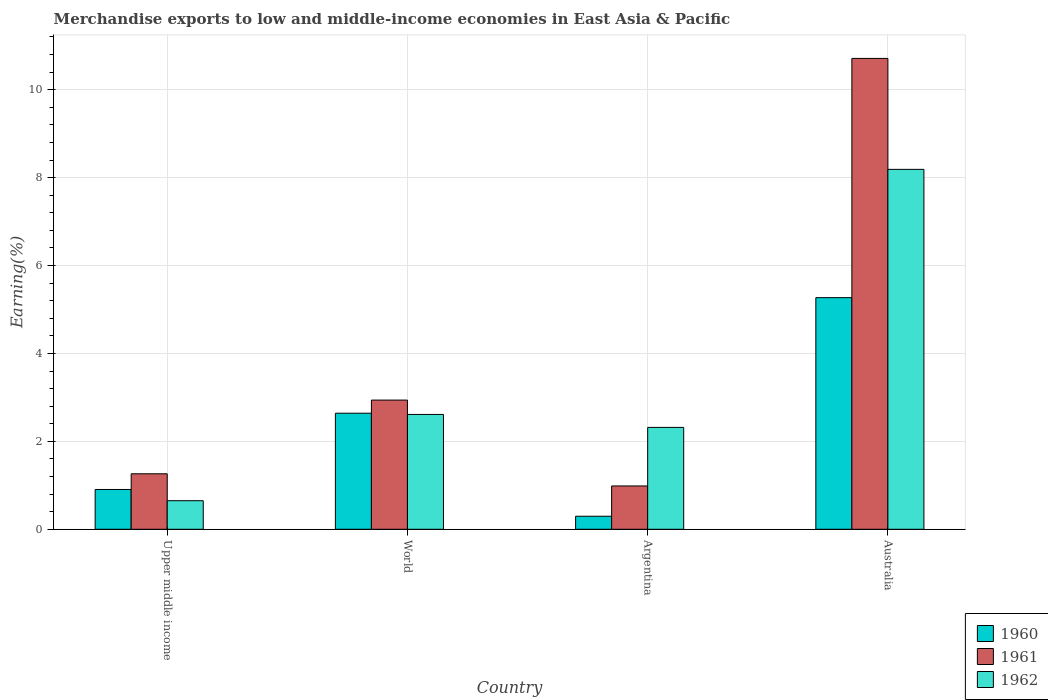How many different coloured bars are there?
Make the answer very short. 3. Are the number of bars per tick equal to the number of legend labels?
Give a very brief answer. Yes. Are the number of bars on each tick of the X-axis equal?
Offer a very short reply. Yes. What is the label of the 3rd group of bars from the left?
Your response must be concise. Argentina. What is the percentage of amount earned from merchandise exports in 1961 in Upper middle income?
Provide a short and direct response. 1.26. Across all countries, what is the maximum percentage of amount earned from merchandise exports in 1960?
Give a very brief answer. 5.27. Across all countries, what is the minimum percentage of amount earned from merchandise exports in 1961?
Provide a succinct answer. 0.99. In which country was the percentage of amount earned from merchandise exports in 1962 minimum?
Keep it short and to the point. Upper middle income. What is the total percentage of amount earned from merchandise exports in 1962 in the graph?
Ensure brevity in your answer.  13.77. What is the difference between the percentage of amount earned from merchandise exports in 1962 in Australia and that in World?
Your response must be concise. 5.58. What is the difference between the percentage of amount earned from merchandise exports in 1962 in Australia and the percentage of amount earned from merchandise exports in 1960 in Argentina?
Offer a very short reply. 7.89. What is the average percentage of amount earned from merchandise exports in 1961 per country?
Keep it short and to the point. 3.97. What is the difference between the percentage of amount earned from merchandise exports of/in 1960 and percentage of amount earned from merchandise exports of/in 1962 in Australia?
Provide a short and direct response. -2.92. What is the ratio of the percentage of amount earned from merchandise exports in 1961 in Australia to that in World?
Your response must be concise. 3.64. Is the percentage of amount earned from merchandise exports in 1961 in Australia less than that in Upper middle income?
Provide a short and direct response. No. What is the difference between the highest and the second highest percentage of amount earned from merchandise exports in 1962?
Keep it short and to the point. 5.58. What is the difference between the highest and the lowest percentage of amount earned from merchandise exports in 1961?
Offer a terse response. 9.73. In how many countries, is the percentage of amount earned from merchandise exports in 1960 greater than the average percentage of amount earned from merchandise exports in 1960 taken over all countries?
Provide a succinct answer. 2. Is the sum of the percentage of amount earned from merchandise exports in 1961 in Australia and Upper middle income greater than the maximum percentage of amount earned from merchandise exports in 1962 across all countries?
Provide a succinct answer. Yes. What does the 1st bar from the left in Argentina represents?
Offer a terse response. 1960. What is the difference between two consecutive major ticks on the Y-axis?
Give a very brief answer. 2. Does the graph contain grids?
Make the answer very short. Yes. Where does the legend appear in the graph?
Make the answer very short. Bottom right. How many legend labels are there?
Offer a terse response. 3. What is the title of the graph?
Provide a succinct answer. Merchandise exports to low and middle-income economies in East Asia & Pacific. Does "2001" appear as one of the legend labels in the graph?
Make the answer very short. No. What is the label or title of the Y-axis?
Offer a terse response. Earning(%). What is the Earning(%) of 1960 in Upper middle income?
Give a very brief answer. 0.91. What is the Earning(%) of 1961 in Upper middle income?
Ensure brevity in your answer.  1.26. What is the Earning(%) in 1962 in Upper middle income?
Provide a short and direct response. 0.65. What is the Earning(%) in 1960 in World?
Your response must be concise. 2.64. What is the Earning(%) in 1961 in World?
Give a very brief answer. 2.94. What is the Earning(%) of 1962 in World?
Provide a short and direct response. 2.61. What is the Earning(%) in 1960 in Argentina?
Your answer should be very brief. 0.3. What is the Earning(%) in 1961 in Argentina?
Keep it short and to the point. 0.99. What is the Earning(%) in 1962 in Argentina?
Provide a short and direct response. 2.32. What is the Earning(%) of 1960 in Australia?
Provide a short and direct response. 5.27. What is the Earning(%) in 1961 in Australia?
Provide a short and direct response. 10.71. What is the Earning(%) in 1962 in Australia?
Provide a succinct answer. 8.19. Across all countries, what is the maximum Earning(%) in 1960?
Keep it short and to the point. 5.27. Across all countries, what is the maximum Earning(%) of 1961?
Your response must be concise. 10.71. Across all countries, what is the maximum Earning(%) of 1962?
Your answer should be compact. 8.19. Across all countries, what is the minimum Earning(%) in 1960?
Offer a terse response. 0.3. Across all countries, what is the minimum Earning(%) in 1961?
Your response must be concise. 0.99. Across all countries, what is the minimum Earning(%) in 1962?
Offer a very short reply. 0.65. What is the total Earning(%) of 1960 in the graph?
Provide a short and direct response. 9.11. What is the total Earning(%) of 1961 in the graph?
Offer a terse response. 15.9. What is the total Earning(%) in 1962 in the graph?
Give a very brief answer. 13.77. What is the difference between the Earning(%) in 1960 in Upper middle income and that in World?
Ensure brevity in your answer.  -1.74. What is the difference between the Earning(%) of 1961 in Upper middle income and that in World?
Ensure brevity in your answer.  -1.68. What is the difference between the Earning(%) of 1962 in Upper middle income and that in World?
Ensure brevity in your answer.  -1.96. What is the difference between the Earning(%) of 1960 in Upper middle income and that in Argentina?
Provide a succinct answer. 0.61. What is the difference between the Earning(%) in 1961 in Upper middle income and that in Argentina?
Keep it short and to the point. 0.28. What is the difference between the Earning(%) in 1962 in Upper middle income and that in Argentina?
Your answer should be very brief. -1.67. What is the difference between the Earning(%) of 1960 in Upper middle income and that in Australia?
Provide a succinct answer. -4.36. What is the difference between the Earning(%) of 1961 in Upper middle income and that in Australia?
Provide a short and direct response. -9.45. What is the difference between the Earning(%) in 1962 in Upper middle income and that in Australia?
Ensure brevity in your answer.  -7.54. What is the difference between the Earning(%) in 1960 in World and that in Argentina?
Keep it short and to the point. 2.34. What is the difference between the Earning(%) in 1961 in World and that in Argentina?
Your answer should be very brief. 1.95. What is the difference between the Earning(%) in 1962 in World and that in Argentina?
Keep it short and to the point. 0.29. What is the difference between the Earning(%) of 1960 in World and that in Australia?
Make the answer very short. -2.63. What is the difference between the Earning(%) of 1961 in World and that in Australia?
Provide a short and direct response. -7.77. What is the difference between the Earning(%) of 1962 in World and that in Australia?
Your answer should be compact. -5.58. What is the difference between the Earning(%) in 1960 in Argentina and that in Australia?
Offer a terse response. -4.97. What is the difference between the Earning(%) in 1961 in Argentina and that in Australia?
Ensure brevity in your answer.  -9.73. What is the difference between the Earning(%) of 1962 in Argentina and that in Australia?
Your response must be concise. -5.87. What is the difference between the Earning(%) of 1960 in Upper middle income and the Earning(%) of 1961 in World?
Ensure brevity in your answer.  -2.03. What is the difference between the Earning(%) in 1960 in Upper middle income and the Earning(%) in 1962 in World?
Make the answer very short. -1.71. What is the difference between the Earning(%) in 1961 in Upper middle income and the Earning(%) in 1962 in World?
Offer a very short reply. -1.35. What is the difference between the Earning(%) of 1960 in Upper middle income and the Earning(%) of 1961 in Argentina?
Provide a short and direct response. -0.08. What is the difference between the Earning(%) in 1960 in Upper middle income and the Earning(%) in 1962 in Argentina?
Your answer should be very brief. -1.41. What is the difference between the Earning(%) of 1961 in Upper middle income and the Earning(%) of 1962 in Argentina?
Ensure brevity in your answer.  -1.06. What is the difference between the Earning(%) of 1960 in Upper middle income and the Earning(%) of 1961 in Australia?
Your response must be concise. -9.81. What is the difference between the Earning(%) in 1960 in Upper middle income and the Earning(%) in 1962 in Australia?
Provide a short and direct response. -7.28. What is the difference between the Earning(%) of 1961 in Upper middle income and the Earning(%) of 1962 in Australia?
Make the answer very short. -6.93. What is the difference between the Earning(%) of 1960 in World and the Earning(%) of 1961 in Argentina?
Offer a very short reply. 1.66. What is the difference between the Earning(%) of 1960 in World and the Earning(%) of 1962 in Argentina?
Offer a very short reply. 0.32. What is the difference between the Earning(%) of 1961 in World and the Earning(%) of 1962 in Argentina?
Your answer should be compact. 0.62. What is the difference between the Earning(%) of 1960 in World and the Earning(%) of 1961 in Australia?
Provide a succinct answer. -8.07. What is the difference between the Earning(%) in 1960 in World and the Earning(%) in 1962 in Australia?
Ensure brevity in your answer.  -5.55. What is the difference between the Earning(%) of 1961 in World and the Earning(%) of 1962 in Australia?
Offer a very short reply. -5.25. What is the difference between the Earning(%) in 1960 in Argentina and the Earning(%) in 1961 in Australia?
Offer a very short reply. -10.42. What is the difference between the Earning(%) in 1960 in Argentina and the Earning(%) in 1962 in Australia?
Keep it short and to the point. -7.89. What is the difference between the Earning(%) of 1961 in Argentina and the Earning(%) of 1962 in Australia?
Ensure brevity in your answer.  -7.2. What is the average Earning(%) in 1960 per country?
Provide a short and direct response. 2.28. What is the average Earning(%) of 1961 per country?
Your answer should be compact. 3.97. What is the average Earning(%) in 1962 per country?
Ensure brevity in your answer.  3.44. What is the difference between the Earning(%) of 1960 and Earning(%) of 1961 in Upper middle income?
Offer a terse response. -0.36. What is the difference between the Earning(%) of 1960 and Earning(%) of 1962 in Upper middle income?
Offer a very short reply. 0.26. What is the difference between the Earning(%) in 1961 and Earning(%) in 1962 in Upper middle income?
Make the answer very short. 0.61. What is the difference between the Earning(%) in 1960 and Earning(%) in 1961 in World?
Provide a short and direct response. -0.3. What is the difference between the Earning(%) in 1960 and Earning(%) in 1962 in World?
Keep it short and to the point. 0.03. What is the difference between the Earning(%) in 1961 and Earning(%) in 1962 in World?
Offer a very short reply. 0.33. What is the difference between the Earning(%) in 1960 and Earning(%) in 1961 in Argentina?
Give a very brief answer. -0.69. What is the difference between the Earning(%) in 1960 and Earning(%) in 1962 in Argentina?
Your answer should be compact. -2.02. What is the difference between the Earning(%) in 1961 and Earning(%) in 1962 in Argentina?
Your answer should be very brief. -1.33. What is the difference between the Earning(%) in 1960 and Earning(%) in 1961 in Australia?
Keep it short and to the point. -5.44. What is the difference between the Earning(%) in 1960 and Earning(%) in 1962 in Australia?
Offer a very short reply. -2.92. What is the difference between the Earning(%) of 1961 and Earning(%) of 1962 in Australia?
Your response must be concise. 2.52. What is the ratio of the Earning(%) of 1960 in Upper middle income to that in World?
Ensure brevity in your answer.  0.34. What is the ratio of the Earning(%) in 1961 in Upper middle income to that in World?
Offer a very short reply. 0.43. What is the ratio of the Earning(%) in 1962 in Upper middle income to that in World?
Give a very brief answer. 0.25. What is the ratio of the Earning(%) of 1960 in Upper middle income to that in Argentina?
Offer a very short reply. 3.05. What is the ratio of the Earning(%) of 1961 in Upper middle income to that in Argentina?
Provide a succinct answer. 1.28. What is the ratio of the Earning(%) of 1962 in Upper middle income to that in Argentina?
Ensure brevity in your answer.  0.28. What is the ratio of the Earning(%) in 1960 in Upper middle income to that in Australia?
Offer a terse response. 0.17. What is the ratio of the Earning(%) in 1961 in Upper middle income to that in Australia?
Provide a succinct answer. 0.12. What is the ratio of the Earning(%) of 1962 in Upper middle income to that in Australia?
Give a very brief answer. 0.08. What is the ratio of the Earning(%) in 1960 in World to that in Argentina?
Your answer should be very brief. 8.9. What is the ratio of the Earning(%) in 1961 in World to that in Argentina?
Keep it short and to the point. 2.98. What is the ratio of the Earning(%) of 1962 in World to that in Argentina?
Ensure brevity in your answer.  1.13. What is the ratio of the Earning(%) in 1960 in World to that in Australia?
Your answer should be compact. 0.5. What is the ratio of the Earning(%) of 1961 in World to that in Australia?
Your response must be concise. 0.27. What is the ratio of the Earning(%) of 1962 in World to that in Australia?
Offer a very short reply. 0.32. What is the ratio of the Earning(%) of 1960 in Argentina to that in Australia?
Your answer should be very brief. 0.06. What is the ratio of the Earning(%) in 1961 in Argentina to that in Australia?
Your answer should be very brief. 0.09. What is the ratio of the Earning(%) of 1962 in Argentina to that in Australia?
Provide a short and direct response. 0.28. What is the difference between the highest and the second highest Earning(%) in 1960?
Offer a terse response. 2.63. What is the difference between the highest and the second highest Earning(%) of 1961?
Provide a succinct answer. 7.77. What is the difference between the highest and the second highest Earning(%) in 1962?
Your answer should be very brief. 5.58. What is the difference between the highest and the lowest Earning(%) in 1960?
Provide a short and direct response. 4.97. What is the difference between the highest and the lowest Earning(%) of 1961?
Ensure brevity in your answer.  9.73. What is the difference between the highest and the lowest Earning(%) of 1962?
Ensure brevity in your answer.  7.54. 